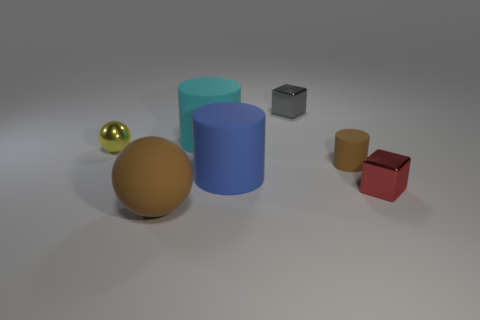Add 1 metal objects. How many objects exist? 8 Subtract all cylinders. How many objects are left? 4 Subtract all shiny blocks. Subtract all large cyan things. How many objects are left? 4 Add 3 cyan things. How many cyan things are left? 4 Add 3 yellow objects. How many yellow objects exist? 4 Subtract 0 green balls. How many objects are left? 7 